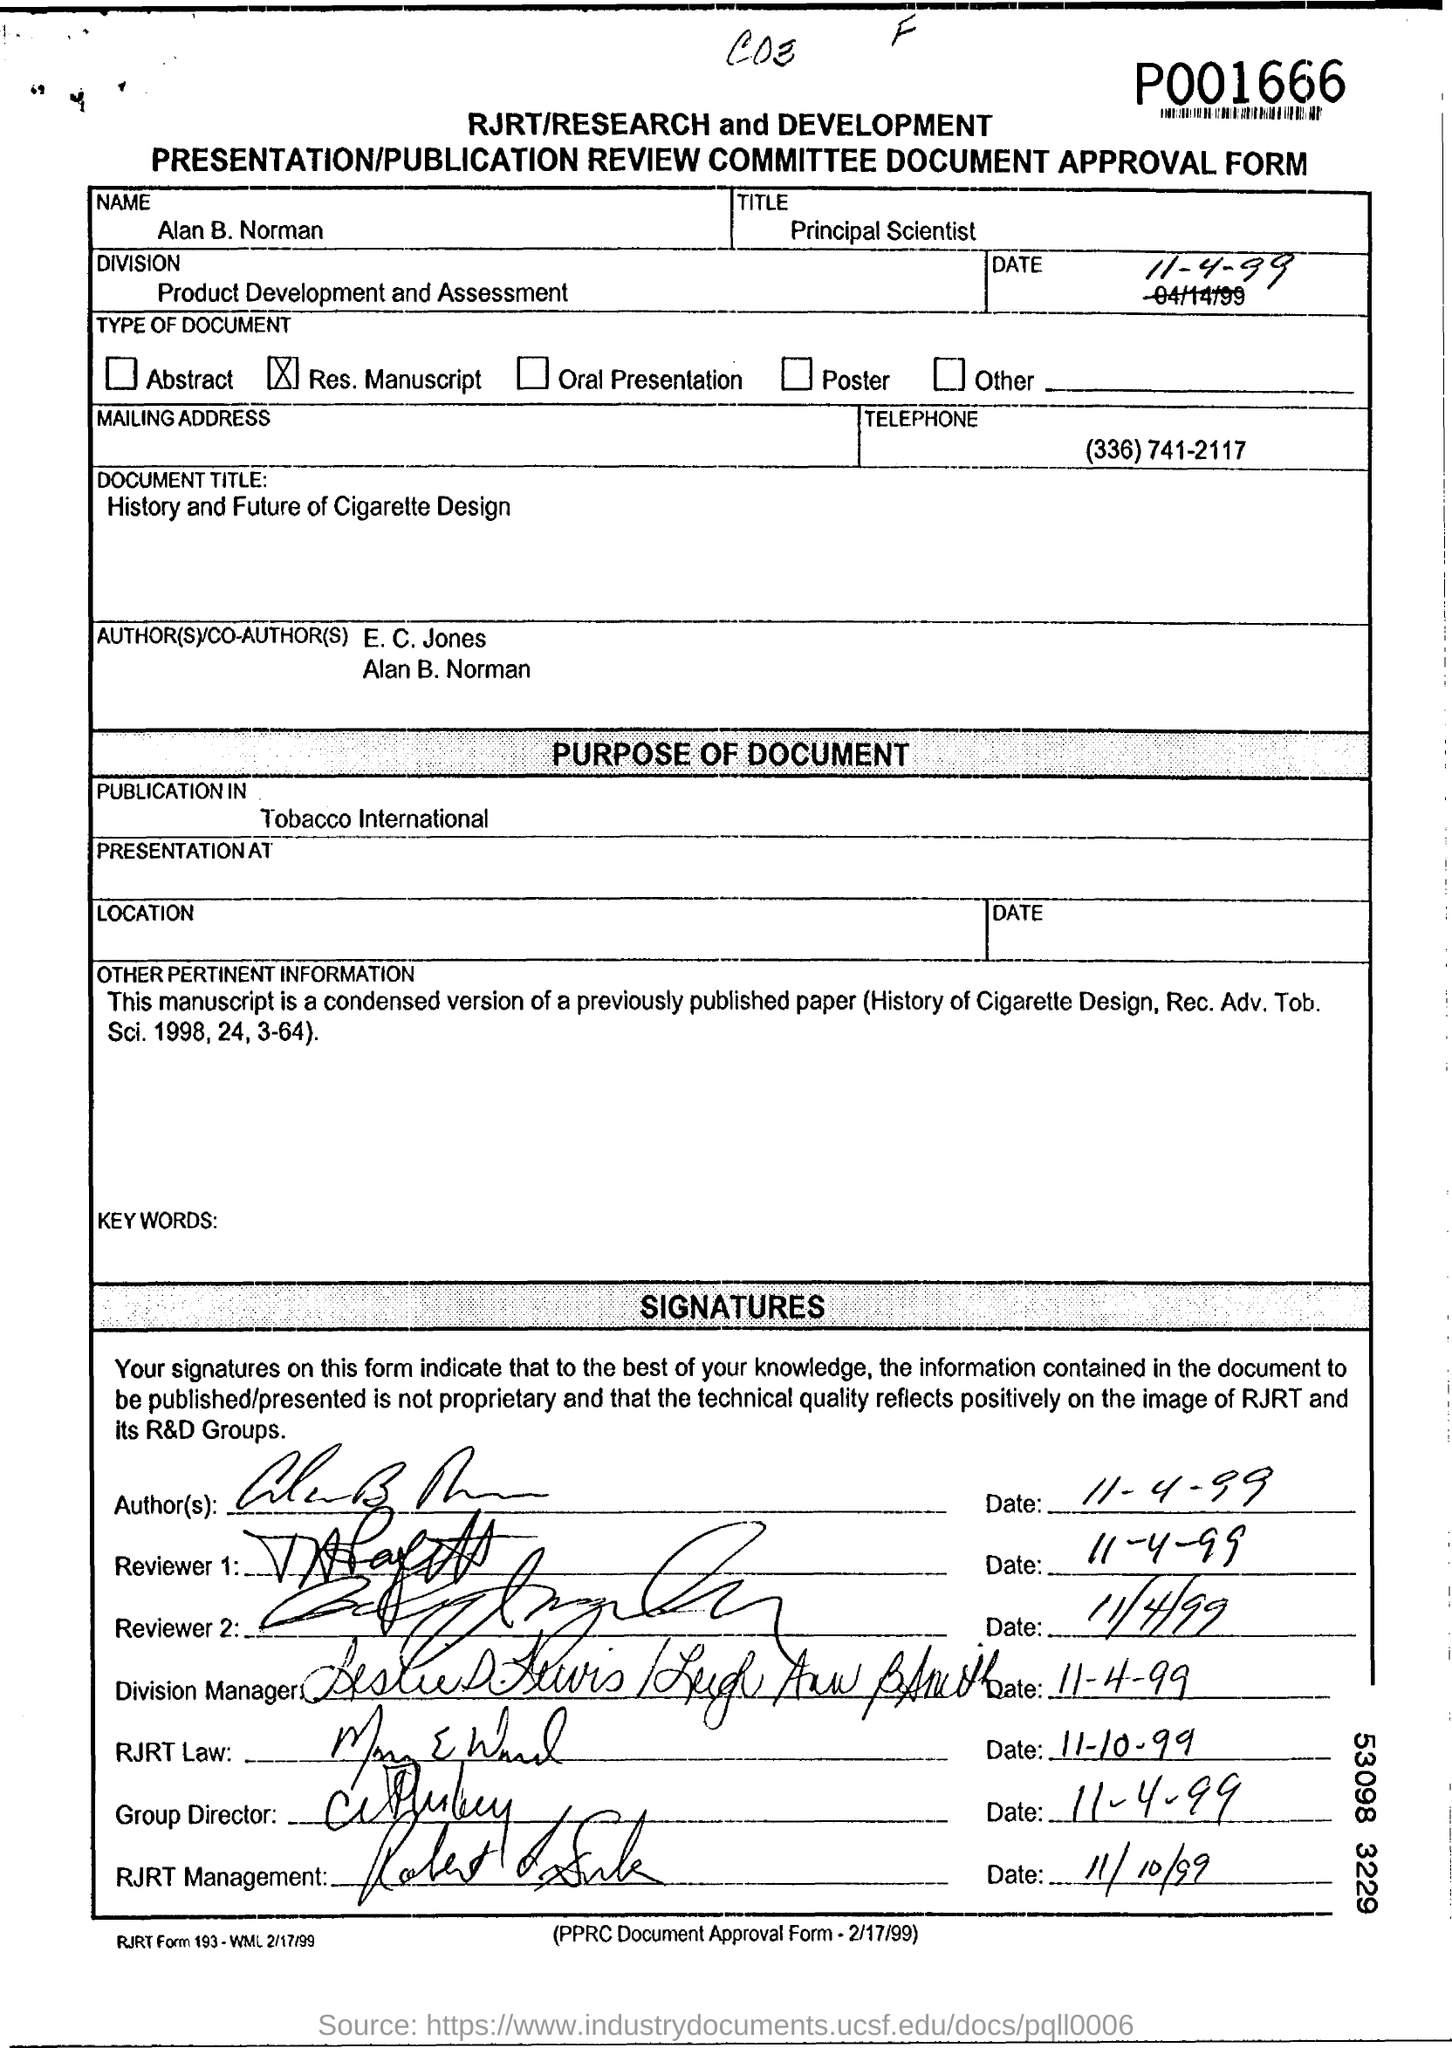What is the name mentioned in the Approval Form ?
Your response must be concise. Alan B. Norman. What is mentioned in the Title Field ?
Your response must be concise. Principal Scientist. What is written in the Division field ?
Your answer should be compact. Product Development and Assessment. What is the date mentioned in the top of the document ?
Provide a succinct answer. 11-4-99. What is written in the Document Title Field ?
Ensure brevity in your answer.  History and Future of Cigarette Design. What is the Telephone Number ?
Make the answer very short. (336) 741-2117. 